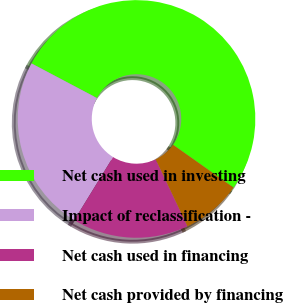<chart> <loc_0><loc_0><loc_500><loc_500><pie_chart><fcel>Net cash used in investing<fcel>Impact of reclassification -<fcel>Net cash used in financing<fcel>Net cash provided by financing<nl><fcel>52.06%<fcel>23.97%<fcel>15.83%<fcel>8.14%<nl></chart> 